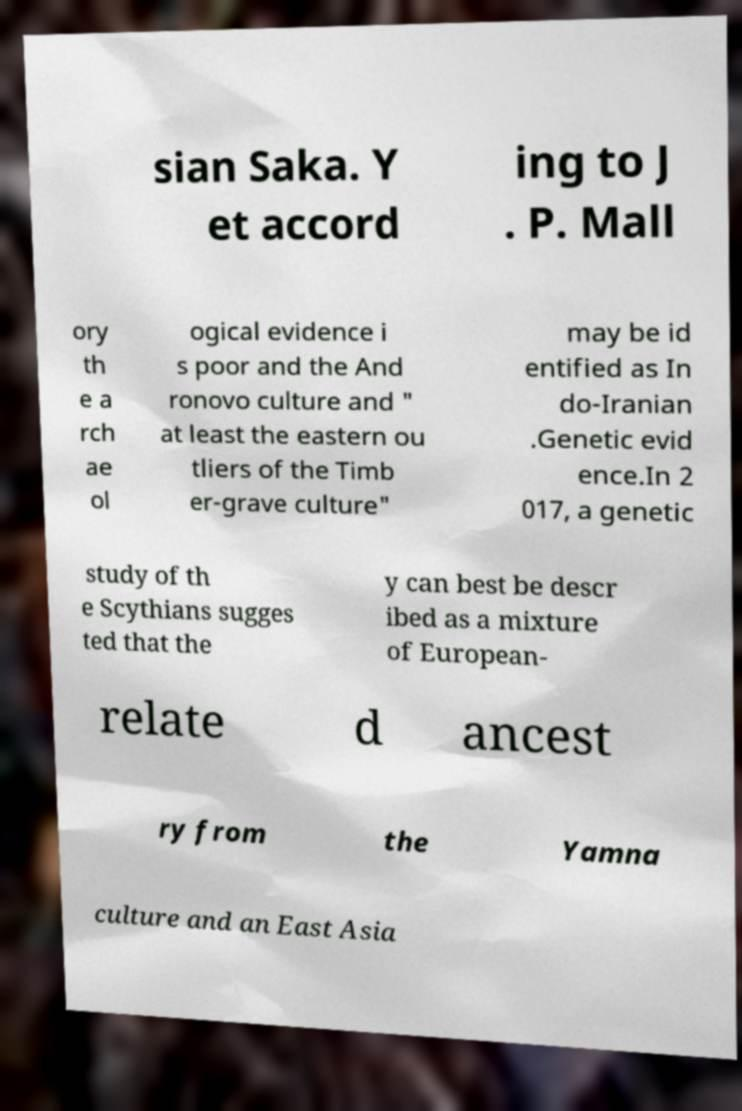For documentation purposes, I need the text within this image transcribed. Could you provide that? sian Saka. Y et accord ing to J . P. Mall ory th e a rch ae ol ogical evidence i s poor and the And ronovo culture and " at least the eastern ou tliers of the Timb er-grave culture" may be id entified as In do-Iranian .Genetic evid ence.In 2 017, a genetic study of th e Scythians sugges ted that the y can best be descr ibed as a mixture of European- relate d ancest ry from the Yamna culture and an East Asia 